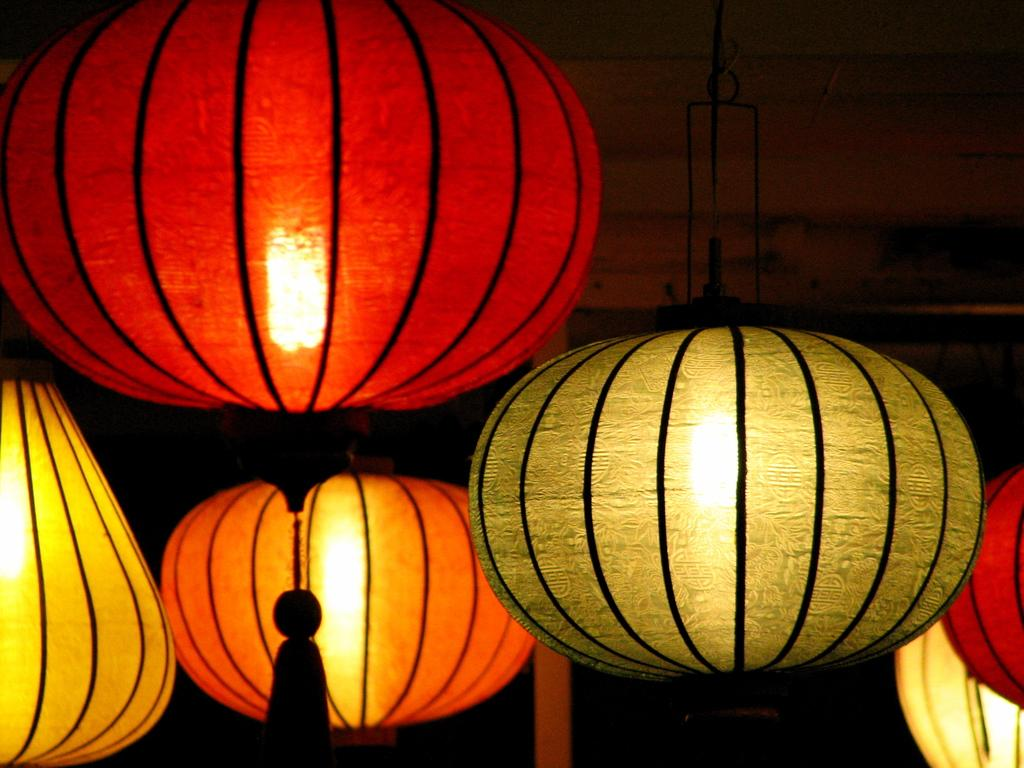What type of lighting is present in the image? There are lanterns in the image. How would you describe the overall lighting in the image? The background of the image is dark. What type of fuel is used to power the lanterns in the image? There is no information provided about the type of fuel used to power the lanterns in the image. 